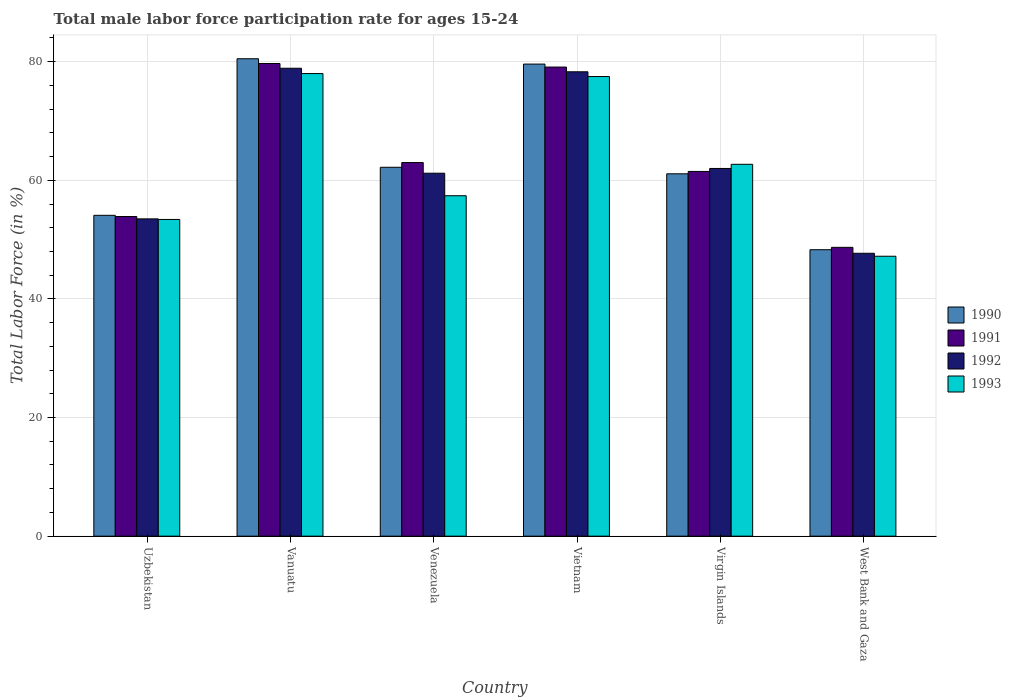What is the label of the 4th group of bars from the left?
Give a very brief answer. Vietnam. What is the male labor force participation rate in 1993 in Vanuatu?
Your answer should be compact. 78. Across all countries, what is the maximum male labor force participation rate in 1991?
Keep it short and to the point. 79.7. Across all countries, what is the minimum male labor force participation rate in 1992?
Provide a succinct answer. 47.7. In which country was the male labor force participation rate in 1991 maximum?
Give a very brief answer. Vanuatu. In which country was the male labor force participation rate in 1992 minimum?
Make the answer very short. West Bank and Gaza. What is the total male labor force participation rate in 1993 in the graph?
Provide a succinct answer. 376.2. What is the difference between the male labor force participation rate in 1990 in Vanuatu and that in Venezuela?
Your answer should be very brief. 18.3. What is the difference between the male labor force participation rate in 1990 in Vietnam and the male labor force participation rate in 1992 in West Bank and Gaza?
Provide a succinct answer. 31.9. What is the average male labor force participation rate in 1993 per country?
Provide a short and direct response. 62.7. What is the difference between the male labor force participation rate of/in 1992 and male labor force participation rate of/in 1993 in West Bank and Gaza?
Ensure brevity in your answer.  0.5. In how many countries, is the male labor force participation rate in 1992 greater than 40 %?
Ensure brevity in your answer.  6. What is the ratio of the male labor force participation rate in 1991 in Venezuela to that in Vietnam?
Your response must be concise. 0.8. What is the difference between the highest and the second highest male labor force participation rate in 1991?
Your response must be concise. -16.1. What is the difference between the highest and the lowest male labor force participation rate in 1991?
Offer a terse response. 31. In how many countries, is the male labor force participation rate in 1990 greater than the average male labor force participation rate in 1990 taken over all countries?
Keep it short and to the point. 2. Is it the case that in every country, the sum of the male labor force participation rate in 1990 and male labor force participation rate in 1993 is greater than the sum of male labor force participation rate in 1991 and male labor force participation rate in 1992?
Offer a terse response. No. How many countries are there in the graph?
Your answer should be compact. 6. Does the graph contain grids?
Offer a terse response. Yes. Where does the legend appear in the graph?
Your answer should be compact. Center right. How many legend labels are there?
Provide a short and direct response. 4. How are the legend labels stacked?
Your answer should be very brief. Vertical. What is the title of the graph?
Offer a terse response. Total male labor force participation rate for ages 15-24. Does "2002" appear as one of the legend labels in the graph?
Provide a succinct answer. No. What is the Total Labor Force (in %) of 1990 in Uzbekistan?
Ensure brevity in your answer.  54.1. What is the Total Labor Force (in %) of 1991 in Uzbekistan?
Provide a short and direct response. 53.9. What is the Total Labor Force (in %) of 1992 in Uzbekistan?
Your answer should be very brief. 53.5. What is the Total Labor Force (in %) of 1993 in Uzbekistan?
Provide a succinct answer. 53.4. What is the Total Labor Force (in %) of 1990 in Vanuatu?
Provide a succinct answer. 80.5. What is the Total Labor Force (in %) of 1991 in Vanuatu?
Provide a short and direct response. 79.7. What is the Total Labor Force (in %) in 1992 in Vanuatu?
Give a very brief answer. 78.9. What is the Total Labor Force (in %) of 1993 in Vanuatu?
Provide a succinct answer. 78. What is the Total Labor Force (in %) of 1990 in Venezuela?
Offer a terse response. 62.2. What is the Total Labor Force (in %) of 1992 in Venezuela?
Make the answer very short. 61.2. What is the Total Labor Force (in %) of 1993 in Venezuela?
Provide a succinct answer. 57.4. What is the Total Labor Force (in %) of 1990 in Vietnam?
Offer a very short reply. 79.6. What is the Total Labor Force (in %) of 1991 in Vietnam?
Provide a short and direct response. 79.1. What is the Total Labor Force (in %) of 1992 in Vietnam?
Your answer should be compact. 78.3. What is the Total Labor Force (in %) in 1993 in Vietnam?
Your answer should be compact. 77.5. What is the Total Labor Force (in %) of 1990 in Virgin Islands?
Ensure brevity in your answer.  61.1. What is the Total Labor Force (in %) of 1991 in Virgin Islands?
Your answer should be very brief. 61.5. What is the Total Labor Force (in %) in 1992 in Virgin Islands?
Make the answer very short. 62. What is the Total Labor Force (in %) of 1993 in Virgin Islands?
Keep it short and to the point. 62.7. What is the Total Labor Force (in %) of 1990 in West Bank and Gaza?
Give a very brief answer. 48.3. What is the Total Labor Force (in %) of 1991 in West Bank and Gaza?
Give a very brief answer. 48.7. What is the Total Labor Force (in %) in 1992 in West Bank and Gaza?
Your answer should be compact. 47.7. What is the Total Labor Force (in %) of 1993 in West Bank and Gaza?
Your answer should be compact. 47.2. Across all countries, what is the maximum Total Labor Force (in %) in 1990?
Ensure brevity in your answer.  80.5. Across all countries, what is the maximum Total Labor Force (in %) in 1991?
Offer a terse response. 79.7. Across all countries, what is the maximum Total Labor Force (in %) in 1992?
Offer a very short reply. 78.9. Across all countries, what is the maximum Total Labor Force (in %) in 1993?
Keep it short and to the point. 78. Across all countries, what is the minimum Total Labor Force (in %) of 1990?
Provide a succinct answer. 48.3. Across all countries, what is the minimum Total Labor Force (in %) of 1991?
Your answer should be very brief. 48.7. Across all countries, what is the minimum Total Labor Force (in %) of 1992?
Give a very brief answer. 47.7. Across all countries, what is the minimum Total Labor Force (in %) of 1993?
Your response must be concise. 47.2. What is the total Total Labor Force (in %) in 1990 in the graph?
Keep it short and to the point. 385.8. What is the total Total Labor Force (in %) of 1991 in the graph?
Make the answer very short. 385.9. What is the total Total Labor Force (in %) in 1992 in the graph?
Ensure brevity in your answer.  381.6. What is the total Total Labor Force (in %) of 1993 in the graph?
Ensure brevity in your answer.  376.2. What is the difference between the Total Labor Force (in %) in 1990 in Uzbekistan and that in Vanuatu?
Keep it short and to the point. -26.4. What is the difference between the Total Labor Force (in %) in 1991 in Uzbekistan and that in Vanuatu?
Offer a terse response. -25.8. What is the difference between the Total Labor Force (in %) in 1992 in Uzbekistan and that in Vanuatu?
Keep it short and to the point. -25.4. What is the difference between the Total Labor Force (in %) in 1993 in Uzbekistan and that in Vanuatu?
Keep it short and to the point. -24.6. What is the difference between the Total Labor Force (in %) of 1990 in Uzbekistan and that in Venezuela?
Offer a terse response. -8.1. What is the difference between the Total Labor Force (in %) in 1991 in Uzbekistan and that in Venezuela?
Ensure brevity in your answer.  -9.1. What is the difference between the Total Labor Force (in %) in 1992 in Uzbekistan and that in Venezuela?
Your response must be concise. -7.7. What is the difference between the Total Labor Force (in %) in 1990 in Uzbekistan and that in Vietnam?
Offer a terse response. -25.5. What is the difference between the Total Labor Force (in %) in 1991 in Uzbekistan and that in Vietnam?
Offer a terse response. -25.2. What is the difference between the Total Labor Force (in %) in 1992 in Uzbekistan and that in Vietnam?
Your response must be concise. -24.8. What is the difference between the Total Labor Force (in %) in 1993 in Uzbekistan and that in Vietnam?
Offer a very short reply. -24.1. What is the difference between the Total Labor Force (in %) in 1991 in Uzbekistan and that in Virgin Islands?
Your response must be concise. -7.6. What is the difference between the Total Labor Force (in %) in 1992 in Uzbekistan and that in Virgin Islands?
Offer a very short reply. -8.5. What is the difference between the Total Labor Force (in %) in 1992 in Uzbekistan and that in West Bank and Gaza?
Your response must be concise. 5.8. What is the difference between the Total Labor Force (in %) of 1993 in Vanuatu and that in Venezuela?
Ensure brevity in your answer.  20.6. What is the difference between the Total Labor Force (in %) in 1990 in Vanuatu and that in Vietnam?
Provide a short and direct response. 0.9. What is the difference between the Total Labor Force (in %) in 1992 in Vanuatu and that in Vietnam?
Give a very brief answer. 0.6. What is the difference between the Total Labor Force (in %) in 1990 in Vanuatu and that in West Bank and Gaza?
Make the answer very short. 32.2. What is the difference between the Total Labor Force (in %) of 1992 in Vanuatu and that in West Bank and Gaza?
Ensure brevity in your answer.  31.2. What is the difference between the Total Labor Force (in %) of 1993 in Vanuatu and that in West Bank and Gaza?
Offer a very short reply. 30.8. What is the difference between the Total Labor Force (in %) of 1990 in Venezuela and that in Vietnam?
Provide a succinct answer. -17.4. What is the difference between the Total Labor Force (in %) in 1991 in Venezuela and that in Vietnam?
Make the answer very short. -16.1. What is the difference between the Total Labor Force (in %) in 1992 in Venezuela and that in Vietnam?
Your answer should be compact. -17.1. What is the difference between the Total Labor Force (in %) of 1993 in Venezuela and that in Vietnam?
Ensure brevity in your answer.  -20.1. What is the difference between the Total Labor Force (in %) of 1991 in Venezuela and that in West Bank and Gaza?
Provide a short and direct response. 14.3. What is the difference between the Total Labor Force (in %) of 1992 in Venezuela and that in West Bank and Gaza?
Offer a very short reply. 13.5. What is the difference between the Total Labor Force (in %) in 1993 in Venezuela and that in West Bank and Gaza?
Your response must be concise. 10.2. What is the difference between the Total Labor Force (in %) of 1990 in Vietnam and that in Virgin Islands?
Ensure brevity in your answer.  18.5. What is the difference between the Total Labor Force (in %) of 1990 in Vietnam and that in West Bank and Gaza?
Offer a terse response. 31.3. What is the difference between the Total Labor Force (in %) of 1991 in Vietnam and that in West Bank and Gaza?
Your answer should be compact. 30.4. What is the difference between the Total Labor Force (in %) in 1992 in Vietnam and that in West Bank and Gaza?
Ensure brevity in your answer.  30.6. What is the difference between the Total Labor Force (in %) in 1993 in Vietnam and that in West Bank and Gaza?
Your response must be concise. 30.3. What is the difference between the Total Labor Force (in %) of 1990 in Virgin Islands and that in West Bank and Gaza?
Keep it short and to the point. 12.8. What is the difference between the Total Labor Force (in %) of 1993 in Virgin Islands and that in West Bank and Gaza?
Your answer should be compact. 15.5. What is the difference between the Total Labor Force (in %) of 1990 in Uzbekistan and the Total Labor Force (in %) of 1991 in Vanuatu?
Offer a very short reply. -25.6. What is the difference between the Total Labor Force (in %) of 1990 in Uzbekistan and the Total Labor Force (in %) of 1992 in Vanuatu?
Provide a short and direct response. -24.8. What is the difference between the Total Labor Force (in %) in 1990 in Uzbekistan and the Total Labor Force (in %) in 1993 in Vanuatu?
Ensure brevity in your answer.  -23.9. What is the difference between the Total Labor Force (in %) in 1991 in Uzbekistan and the Total Labor Force (in %) in 1993 in Vanuatu?
Give a very brief answer. -24.1. What is the difference between the Total Labor Force (in %) of 1992 in Uzbekistan and the Total Labor Force (in %) of 1993 in Vanuatu?
Your answer should be compact. -24.5. What is the difference between the Total Labor Force (in %) in 1990 in Uzbekistan and the Total Labor Force (in %) in 1991 in Venezuela?
Ensure brevity in your answer.  -8.9. What is the difference between the Total Labor Force (in %) in 1990 in Uzbekistan and the Total Labor Force (in %) in 1993 in Venezuela?
Make the answer very short. -3.3. What is the difference between the Total Labor Force (in %) in 1992 in Uzbekistan and the Total Labor Force (in %) in 1993 in Venezuela?
Keep it short and to the point. -3.9. What is the difference between the Total Labor Force (in %) in 1990 in Uzbekistan and the Total Labor Force (in %) in 1992 in Vietnam?
Your answer should be compact. -24.2. What is the difference between the Total Labor Force (in %) of 1990 in Uzbekistan and the Total Labor Force (in %) of 1993 in Vietnam?
Provide a short and direct response. -23.4. What is the difference between the Total Labor Force (in %) in 1991 in Uzbekistan and the Total Labor Force (in %) in 1992 in Vietnam?
Give a very brief answer. -24.4. What is the difference between the Total Labor Force (in %) in 1991 in Uzbekistan and the Total Labor Force (in %) in 1993 in Vietnam?
Your answer should be very brief. -23.6. What is the difference between the Total Labor Force (in %) in 1990 in Uzbekistan and the Total Labor Force (in %) in 1991 in Virgin Islands?
Your answer should be compact. -7.4. What is the difference between the Total Labor Force (in %) in 1990 in Uzbekistan and the Total Labor Force (in %) in 1993 in Virgin Islands?
Keep it short and to the point. -8.6. What is the difference between the Total Labor Force (in %) of 1991 in Uzbekistan and the Total Labor Force (in %) of 1992 in Virgin Islands?
Keep it short and to the point. -8.1. What is the difference between the Total Labor Force (in %) in 1991 in Uzbekistan and the Total Labor Force (in %) in 1993 in Virgin Islands?
Keep it short and to the point. -8.8. What is the difference between the Total Labor Force (in %) in 1992 in Uzbekistan and the Total Labor Force (in %) in 1993 in Virgin Islands?
Make the answer very short. -9.2. What is the difference between the Total Labor Force (in %) of 1990 in Uzbekistan and the Total Labor Force (in %) of 1991 in West Bank and Gaza?
Give a very brief answer. 5.4. What is the difference between the Total Labor Force (in %) in 1990 in Uzbekistan and the Total Labor Force (in %) in 1992 in West Bank and Gaza?
Make the answer very short. 6.4. What is the difference between the Total Labor Force (in %) in 1990 in Uzbekistan and the Total Labor Force (in %) in 1993 in West Bank and Gaza?
Provide a succinct answer. 6.9. What is the difference between the Total Labor Force (in %) of 1990 in Vanuatu and the Total Labor Force (in %) of 1992 in Venezuela?
Your answer should be compact. 19.3. What is the difference between the Total Labor Force (in %) in 1990 in Vanuatu and the Total Labor Force (in %) in 1993 in Venezuela?
Keep it short and to the point. 23.1. What is the difference between the Total Labor Force (in %) in 1991 in Vanuatu and the Total Labor Force (in %) in 1992 in Venezuela?
Offer a terse response. 18.5. What is the difference between the Total Labor Force (in %) of 1991 in Vanuatu and the Total Labor Force (in %) of 1993 in Venezuela?
Keep it short and to the point. 22.3. What is the difference between the Total Labor Force (in %) in 1992 in Vanuatu and the Total Labor Force (in %) in 1993 in Venezuela?
Your answer should be compact. 21.5. What is the difference between the Total Labor Force (in %) in 1990 in Vanuatu and the Total Labor Force (in %) in 1991 in Vietnam?
Keep it short and to the point. 1.4. What is the difference between the Total Labor Force (in %) in 1990 in Vanuatu and the Total Labor Force (in %) in 1993 in Vietnam?
Provide a succinct answer. 3. What is the difference between the Total Labor Force (in %) in 1991 in Vanuatu and the Total Labor Force (in %) in 1992 in Vietnam?
Keep it short and to the point. 1.4. What is the difference between the Total Labor Force (in %) in 1990 in Vanuatu and the Total Labor Force (in %) in 1991 in Virgin Islands?
Give a very brief answer. 19. What is the difference between the Total Labor Force (in %) of 1990 in Vanuatu and the Total Labor Force (in %) of 1992 in Virgin Islands?
Your answer should be compact. 18.5. What is the difference between the Total Labor Force (in %) in 1991 in Vanuatu and the Total Labor Force (in %) in 1992 in Virgin Islands?
Make the answer very short. 17.7. What is the difference between the Total Labor Force (in %) of 1991 in Vanuatu and the Total Labor Force (in %) of 1993 in Virgin Islands?
Your response must be concise. 17. What is the difference between the Total Labor Force (in %) of 1990 in Vanuatu and the Total Labor Force (in %) of 1991 in West Bank and Gaza?
Your response must be concise. 31.8. What is the difference between the Total Labor Force (in %) of 1990 in Vanuatu and the Total Labor Force (in %) of 1992 in West Bank and Gaza?
Keep it short and to the point. 32.8. What is the difference between the Total Labor Force (in %) in 1990 in Vanuatu and the Total Labor Force (in %) in 1993 in West Bank and Gaza?
Offer a very short reply. 33.3. What is the difference between the Total Labor Force (in %) in 1991 in Vanuatu and the Total Labor Force (in %) in 1993 in West Bank and Gaza?
Provide a short and direct response. 32.5. What is the difference between the Total Labor Force (in %) in 1992 in Vanuatu and the Total Labor Force (in %) in 1993 in West Bank and Gaza?
Your response must be concise. 31.7. What is the difference between the Total Labor Force (in %) of 1990 in Venezuela and the Total Labor Force (in %) of 1991 in Vietnam?
Your answer should be very brief. -16.9. What is the difference between the Total Labor Force (in %) of 1990 in Venezuela and the Total Labor Force (in %) of 1992 in Vietnam?
Offer a terse response. -16.1. What is the difference between the Total Labor Force (in %) in 1990 in Venezuela and the Total Labor Force (in %) in 1993 in Vietnam?
Your answer should be very brief. -15.3. What is the difference between the Total Labor Force (in %) in 1991 in Venezuela and the Total Labor Force (in %) in 1992 in Vietnam?
Offer a terse response. -15.3. What is the difference between the Total Labor Force (in %) of 1991 in Venezuela and the Total Labor Force (in %) of 1993 in Vietnam?
Give a very brief answer. -14.5. What is the difference between the Total Labor Force (in %) of 1992 in Venezuela and the Total Labor Force (in %) of 1993 in Vietnam?
Offer a terse response. -16.3. What is the difference between the Total Labor Force (in %) in 1990 in Venezuela and the Total Labor Force (in %) in 1992 in Virgin Islands?
Your answer should be very brief. 0.2. What is the difference between the Total Labor Force (in %) of 1992 in Venezuela and the Total Labor Force (in %) of 1993 in Virgin Islands?
Give a very brief answer. -1.5. What is the difference between the Total Labor Force (in %) in 1990 in Venezuela and the Total Labor Force (in %) in 1991 in West Bank and Gaza?
Keep it short and to the point. 13.5. What is the difference between the Total Labor Force (in %) of 1990 in Venezuela and the Total Labor Force (in %) of 1992 in West Bank and Gaza?
Your answer should be very brief. 14.5. What is the difference between the Total Labor Force (in %) in 1990 in Venezuela and the Total Labor Force (in %) in 1993 in West Bank and Gaza?
Offer a terse response. 15. What is the difference between the Total Labor Force (in %) of 1991 in Venezuela and the Total Labor Force (in %) of 1993 in West Bank and Gaza?
Your answer should be compact. 15.8. What is the difference between the Total Labor Force (in %) in 1990 in Vietnam and the Total Labor Force (in %) in 1991 in Virgin Islands?
Your response must be concise. 18.1. What is the difference between the Total Labor Force (in %) in 1990 in Vietnam and the Total Labor Force (in %) in 1993 in Virgin Islands?
Offer a terse response. 16.9. What is the difference between the Total Labor Force (in %) in 1991 in Vietnam and the Total Labor Force (in %) in 1992 in Virgin Islands?
Give a very brief answer. 17.1. What is the difference between the Total Labor Force (in %) of 1991 in Vietnam and the Total Labor Force (in %) of 1993 in Virgin Islands?
Give a very brief answer. 16.4. What is the difference between the Total Labor Force (in %) of 1990 in Vietnam and the Total Labor Force (in %) of 1991 in West Bank and Gaza?
Provide a succinct answer. 30.9. What is the difference between the Total Labor Force (in %) of 1990 in Vietnam and the Total Labor Force (in %) of 1992 in West Bank and Gaza?
Keep it short and to the point. 31.9. What is the difference between the Total Labor Force (in %) in 1990 in Vietnam and the Total Labor Force (in %) in 1993 in West Bank and Gaza?
Offer a terse response. 32.4. What is the difference between the Total Labor Force (in %) of 1991 in Vietnam and the Total Labor Force (in %) of 1992 in West Bank and Gaza?
Make the answer very short. 31.4. What is the difference between the Total Labor Force (in %) of 1991 in Vietnam and the Total Labor Force (in %) of 1993 in West Bank and Gaza?
Keep it short and to the point. 31.9. What is the difference between the Total Labor Force (in %) of 1992 in Vietnam and the Total Labor Force (in %) of 1993 in West Bank and Gaza?
Ensure brevity in your answer.  31.1. What is the difference between the Total Labor Force (in %) of 1990 in Virgin Islands and the Total Labor Force (in %) of 1992 in West Bank and Gaza?
Your response must be concise. 13.4. What is the difference between the Total Labor Force (in %) in 1991 in Virgin Islands and the Total Labor Force (in %) in 1993 in West Bank and Gaza?
Your response must be concise. 14.3. What is the average Total Labor Force (in %) in 1990 per country?
Provide a short and direct response. 64.3. What is the average Total Labor Force (in %) in 1991 per country?
Ensure brevity in your answer.  64.32. What is the average Total Labor Force (in %) in 1992 per country?
Offer a terse response. 63.6. What is the average Total Labor Force (in %) in 1993 per country?
Provide a succinct answer. 62.7. What is the difference between the Total Labor Force (in %) in 1990 and Total Labor Force (in %) in 1991 in Uzbekistan?
Keep it short and to the point. 0.2. What is the difference between the Total Labor Force (in %) of 1990 and Total Labor Force (in %) of 1992 in Uzbekistan?
Provide a short and direct response. 0.6. What is the difference between the Total Labor Force (in %) of 1990 and Total Labor Force (in %) of 1993 in Uzbekistan?
Provide a succinct answer. 0.7. What is the difference between the Total Labor Force (in %) of 1991 and Total Labor Force (in %) of 1992 in Uzbekistan?
Ensure brevity in your answer.  0.4. What is the difference between the Total Labor Force (in %) in 1991 and Total Labor Force (in %) in 1993 in Uzbekistan?
Provide a succinct answer. 0.5. What is the difference between the Total Labor Force (in %) of 1992 and Total Labor Force (in %) of 1993 in Uzbekistan?
Your answer should be very brief. 0.1. What is the difference between the Total Labor Force (in %) in 1990 and Total Labor Force (in %) in 1993 in Vanuatu?
Make the answer very short. 2.5. What is the difference between the Total Labor Force (in %) in 1991 and Total Labor Force (in %) in 1993 in Vanuatu?
Your answer should be very brief. 1.7. What is the difference between the Total Labor Force (in %) in 1990 and Total Labor Force (in %) in 1991 in Venezuela?
Your response must be concise. -0.8. What is the difference between the Total Labor Force (in %) in 1990 and Total Labor Force (in %) in 1992 in Venezuela?
Your answer should be compact. 1. What is the difference between the Total Labor Force (in %) in 1990 and Total Labor Force (in %) in 1993 in Venezuela?
Your response must be concise. 4.8. What is the difference between the Total Labor Force (in %) in 1991 and Total Labor Force (in %) in 1992 in Venezuela?
Offer a very short reply. 1.8. What is the difference between the Total Labor Force (in %) of 1991 and Total Labor Force (in %) of 1993 in Venezuela?
Provide a succinct answer. 5.6. What is the difference between the Total Labor Force (in %) of 1992 and Total Labor Force (in %) of 1993 in Venezuela?
Give a very brief answer. 3.8. What is the difference between the Total Labor Force (in %) in 1990 and Total Labor Force (in %) in 1992 in Vietnam?
Give a very brief answer. 1.3. What is the difference between the Total Labor Force (in %) in 1992 and Total Labor Force (in %) in 1993 in Vietnam?
Provide a short and direct response. 0.8. What is the difference between the Total Labor Force (in %) of 1990 and Total Labor Force (in %) of 1991 in Virgin Islands?
Ensure brevity in your answer.  -0.4. What is the difference between the Total Labor Force (in %) in 1990 and Total Labor Force (in %) in 1992 in Virgin Islands?
Your answer should be very brief. -0.9. What is the difference between the Total Labor Force (in %) of 1991 and Total Labor Force (in %) of 1992 in Virgin Islands?
Ensure brevity in your answer.  -0.5. What is the difference between the Total Labor Force (in %) of 1992 and Total Labor Force (in %) of 1993 in Virgin Islands?
Provide a short and direct response. -0.7. What is the difference between the Total Labor Force (in %) in 1990 and Total Labor Force (in %) in 1993 in West Bank and Gaza?
Your response must be concise. 1.1. What is the difference between the Total Labor Force (in %) in 1991 and Total Labor Force (in %) in 1992 in West Bank and Gaza?
Make the answer very short. 1. What is the difference between the Total Labor Force (in %) in 1991 and Total Labor Force (in %) in 1993 in West Bank and Gaza?
Provide a succinct answer. 1.5. What is the ratio of the Total Labor Force (in %) of 1990 in Uzbekistan to that in Vanuatu?
Give a very brief answer. 0.67. What is the ratio of the Total Labor Force (in %) in 1991 in Uzbekistan to that in Vanuatu?
Your answer should be very brief. 0.68. What is the ratio of the Total Labor Force (in %) of 1992 in Uzbekistan to that in Vanuatu?
Ensure brevity in your answer.  0.68. What is the ratio of the Total Labor Force (in %) in 1993 in Uzbekistan to that in Vanuatu?
Offer a terse response. 0.68. What is the ratio of the Total Labor Force (in %) of 1990 in Uzbekistan to that in Venezuela?
Ensure brevity in your answer.  0.87. What is the ratio of the Total Labor Force (in %) in 1991 in Uzbekistan to that in Venezuela?
Offer a terse response. 0.86. What is the ratio of the Total Labor Force (in %) of 1992 in Uzbekistan to that in Venezuela?
Offer a terse response. 0.87. What is the ratio of the Total Labor Force (in %) in 1993 in Uzbekistan to that in Venezuela?
Provide a succinct answer. 0.93. What is the ratio of the Total Labor Force (in %) in 1990 in Uzbekistan to that in Vietnam?
Provide a short and direct response. 0.68. What is the ratio of the Total Labor Force (in %) of 1991 in Uzbekistan to that in Vietnam?
Provide a short and direct response. 0.68. What is the ratio of the Total Labor Force (in %) of 1992 in Uzbekistan to that in Vietnam?
Your answer should be very brief. 0.68. What is the ratio of the Total Labor Force (in %) in 1993 in Uzbekistan to that in Vietnam?
Make the answer very short. 0.69. What is the ratio of the Total Labor Force (in %) of 1990 in Uzbekistan to that in Virgin Islands?
Provide a short and direct response. 0.89. What is the ratio of the Total Labor Force (in %) in 1991 in Uzbekistan to that in Virgin Islands?
Provide a short and direct response. 0.88. What is the ratio of the Total Labor Force (in %) of 1992 in Uzbekistan to that in Virgin Islands?
Keep it short and to the point. 0.86. What is the ratio of the Total Labor Force (in %) of 1993 in Uzbekistan to that in Virgin Islands?
Give a very brief answer. 0.85. What is the ratio of the Total Labor Force (in %) of 1990 in Uzbekistan to that in West Bank and Gaza?
Your answer should be compact. 1.12. What is the ratio of the Total Labor Force (in %) in 1991 in Uzbekistan to that in West Bank and Gaza?
Make the answer very short. 1.11. What is the ratio of the Total Labor Force (in %) in 1992 in Uzbekistan to that in West Bank and Gaza?
Your answer should be compact. 1.12. What is the ratio of the Total Labor Force (in %) in 1993 in Uzbekistan to that in West Bank and Gaza?
Make the answer very short. 1.13. What is the ratio of the Total Labor Force (in %) of 1990 in Vanuatu to that in Venezuela?
Give a very brief answer. 1.29. What is the ratio of the Total Labor Force (in %) of 1991 in Vanuatu to that in Venezuela?
Provide a short and direct response. 1.27. What is the ratio of the Total Labor Force (in %) of 1992 in Vanuatu to that in Venezuela?
Make the answer very short. 1.29. What is the ratio of the Total Labor Force (in %) in 1993 in Vanuatu to that in Venezuela?
Your response must be concise. 1.36. What is the ratio of the Total Labor Force (in %) in 1990 in Vanuatu to that in Vietnam?
Give a very brief answer. 1.01. What is the ratio of the Total Labor Force (in %) of 1991 in Vanuatu to that in Vietnam?
Provide a short and direct response. 1.01. What is the ratio of the Total Labor Force (in %) of 1992 in Vanuatu to that in Vietnam?
Your response must be concise. 1.01. What is the ratio of the Total Labor Force (in %) in 1993 in Vanuatu to that in Vietnam?
Ensure brevity in your answer.  1.01. What is the ratio of the Total Labor Force (in %) of 1990 in Vanuatu to that in Virgin Islands?
Offer a terse response. 1.32. What is the ratio of the Total Labor Force (in %) in 1991 in Vanuatu to that in Virgin Islands?
Provide a succinct answer. 1.3. What is the ratio of the Total Labor Force (in %) in 1992 in Vanuatu to that in Virgin Islands?
Your response must be concise. 1.27. What is the ratio of the Total Labor Force (in %) of 1993 in Vanuatu to that in Virgin Islands?
Offer a terse response. 1.24. What is the ratio of the Total Labor Force (in %) in 1990 in Vanuatu to that in West Bank and Gaza?
Your answer should be compact. 1.67. What is the ratio of the Total Labor Force (in %) in 1991 in Vanuatu to that in West Bank and Gaza?
Keep it short and to the point. 1.64. What is the ratio of the Total Labor Force (in %) in 1992 in Vanuatu to that in West Bank and Gaza?
Keep it short and to the point. 1.65. What is the ratio of the Total Labor Force (in %) in 1993 in Vanuatu to that in West Bank and Gaza?
Give a very brief answer. 1.65. What is the ratio of the Total Labor Force (in %) of 1990 in Venezuela to that in Vietnam?
Provide a succinct answer. 0.78. What is the ratio of the Total Labor Force (in %) in 1991 in Venezuela to that in Vietnam?
Your answer should be compact. 0.8. What is the ratio of the Total Labor Force (in %) of 1992 in Venezuela to that in Vietnam?
Give a very brief answer. 0.78. What is the ratio of the Total Labor Force (in %) of 1993 in Venezuela to that in Vietnam?
Provide a short and direct response. 0.74. What is the ratio of the Total Labor Force (in %) of 1990 in Venezuela to that in Virgin Islands?
Your answer should be compact. 1.02. What is the ratio of the Total Labor Force (in %) in 1991 in Venezuela to that in Virgin Islands?
Keep it short and to the point. 1.02. What is the ratio of the Total Labor Force (in %) of 1992 in Venezuela to that in Virgin Islands?
Offer a very short reply. 0.99. What is the ratio of the Total Labor Force (in %) in 1993 in Venezuela to that in Virgin Islands?
Offer a terse response. 0.92. What is the ratio of the Total Labor Force (in %) of 1990 in Venezuela to that in West Bank and Gaza?
Your response must be concise. 1.29. What is the ratio of the Total Labor Force (in %) of 1991 in Venezuela to that in West Bank and Gaza?
Ensure brevity in your answer.  1.29. What is the ratio of the Total Labor Force (in %) in 1992 in Venezuela to that in West Bank and Gaza?
Your answer should be very brief. 1.28. What is the ratio of the Total Labor Force (in %) of 1993 in Venezuela to that in West Bank and Gaza?
Ensure brevity in your answer.  1.22. What is the ratio of the Total Labor Force (in %) of 1990 in Vietnam to that in Virgin Islands?
Provide a short and direct response. 1.3. What is the ratio of the Total Labor Force (in %) in 1991 in Vietnam to that in Virgin Islands?
Give a very brief answer. 1.29. What is the ratio of the Total Labor Force (in %) in 1992 in Vietnam to that in Virgin Islands?
Offer a very short reply. 1.26. What is the ratio of the Total Labor Force (in %) of 1993 in Vietnam to that in Virgin Islands?
Provide a short and direct response. 1.24. What is the ratio of the Total Labor Force (in %) in 1990 in Vietnam to that in West Bank and Gaza?
Offer a very short reply. 1.65. What is the ratio of the Total Labor Force (in %) of 1991 in Vietnam to that in West Bank and Gaza?
Your answer should be compact. 1.62. What is the ratio of the Total Labor Force (in %) in 1992 in Vietnam to that in West Bank and Gaza?
Your response must be concise. 1.64. What is the ratio of the Total Labor Force (in %) in 1993 in Vietnam to that in West Bank and Gaza?
Ensure brevity in your answer.  1.64. What is the ratio of the Total Labor Force (in %) in 1990 in Virgin Islands to that in West Bank and Gaza?
Provide a short and direct response. 1.26. What is the ratio of the Total Labor Force (in %) of 1991 in Virgin Islands to that in West Bank and Gaza?
Make the answer very short. 1.26. What is the ratio of the Total Labor Force (in %) of 1992 in Virgin Islands to that in West Bank and Gaza?
Provide a succinct answer. 1.3. What is the ratio of the Total Labor Force (in %) of 1993 in Virgin Islands to that in West Bank and Gaza?
Keep it short and to the point. 1.33. What is the difference between the highest and the second highest Total Labor Force (in %) of 1990?
Your answer should be very brief. 0.9. What is the difference between the highest and the second highest Total Labor Force (in %) of 1993?
Provide a succinct answer. 0.5. What is the difference between the highest and the lowest Total Labor Force (in %) of 1990?
Provide a short and direct response. 32.2. What is the difference between the highest and the lowest Total Labor Force (in %) of 1991?
Keep it short and to the point. 31. What is the difference between the highest and the lowest Total Labor Force (in %) of 1992?
Ensure brevity in your answer.  31.2. What is the difference between the highest and the lowest Total Labor Force (in %) in 1993?
Provide a short and direct response. 30.8. 